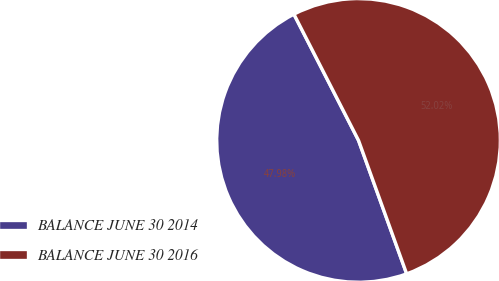Convert chart to OTSL. <chart><loc_0><loc_0><loc_500><loc_500><pie_chart><fcel>BALANCE JUNE 30 2014<fcel>BALANCE JUNE 30 2016<nl><fcel>47.98%<fcel>52.02%<nl></chart> 